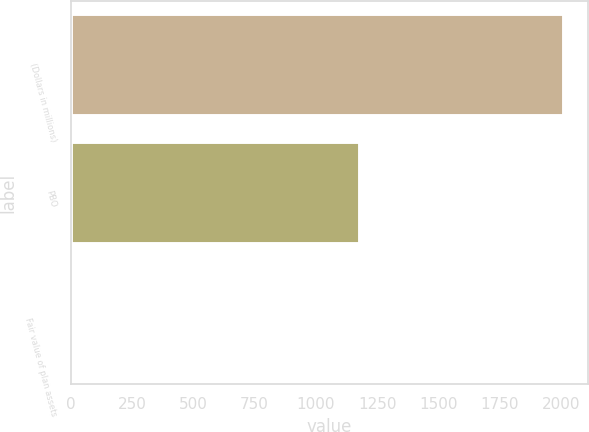Convert chart. <chart><loc_0><loc_0><loc_500><loc_500><bar_chart><fcel>(Dollars in millions)<fcel>PBO<fcel>Fair value of plan assets<nl><fcel>2012<fcel>1182<fcel>2<nl></chart> 